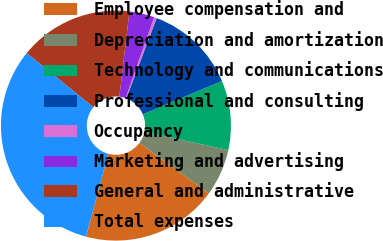Convert chart. <chart><loc_0><loc_0><loc_500><loc_500><pie_chart><fcel>Employee compensation and<fcel>Depreciation and amortization<fcel>Technology and communications<fcel>Professional and consulting<fcel>Occupancy<fcel>Marketing and advertising<fcel>General and administrative<fcel>Total expenses<nl><fcel>19.15%<fcel>6.64%<fcel>9.76%<fcel>12.89%<fcel>0.38%<fcel>3.51%<fcel>16.02%<fcel>31.65%<nl></chart> 